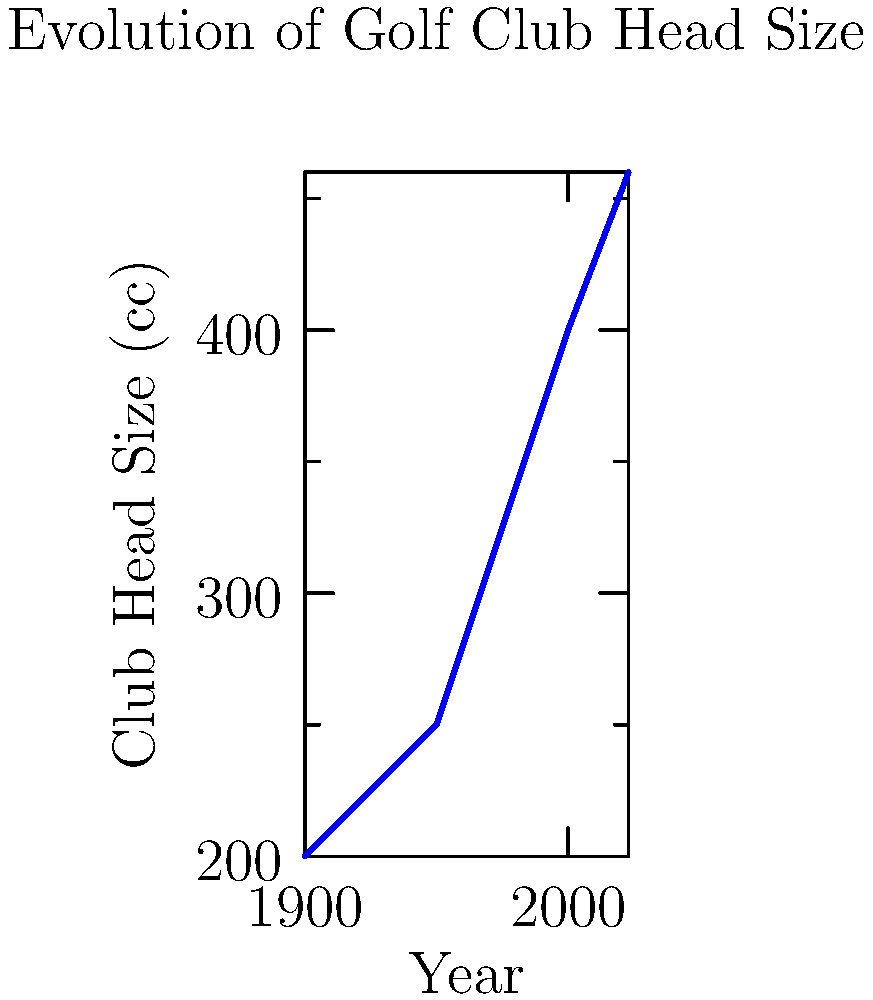Based on the graph showing the evolution of golf club head sizes, what is the approximate size (in cubic centimeters) of a modern driver head in 2023? To determine the approximate size of a modern driver head in 2023, we need to follow these steps:

1. Examine the graph, which shows the evolution of golf club head sizes over time.
2. Locate the year 2023 on the x-axis.
3. Find the corresponding point on the blue line for the year 2023.
4. Read the value on the y-axis that corresponds to this point.

Looking at the graph, we can see that:
1. The x-axis represents years from 1900 to 2023.
2. The y-axis represents club head size in cubic centimeters (cc).
3. The blue line shows an increasing trend in club head size over time.
4. For the year 2023, the line reaches a point that corresponds to approximately 460 cc on the y-axis.

Therefore, based on this graph, the approximate size of a modern driver head in 2023 is 460 cc.
Answer: 460 cc 